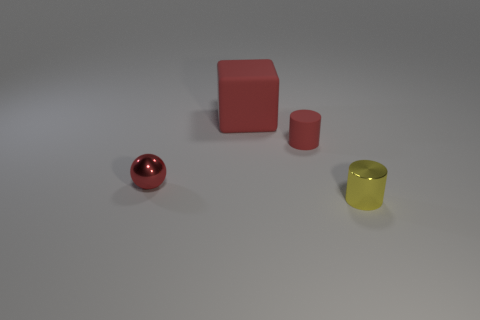Add 4 small things. How many objects exist? 8 Add 2 tiny cyan rubber blocks. How many tiny cyan rubber blocks exist? 2 Subtract 0 blue balls. How many objects are left? 4 Subtract all spheres. How many objects are left? 3 Subtract all brown balls. Subtract all yellow cylinders. How many balls are left? 1 Subtract all big blue objects. Subtract all small red cylinders. How many objects are left? 3 Add 4 small red matte cylinders. How many small red matte cylinders are left? 5 